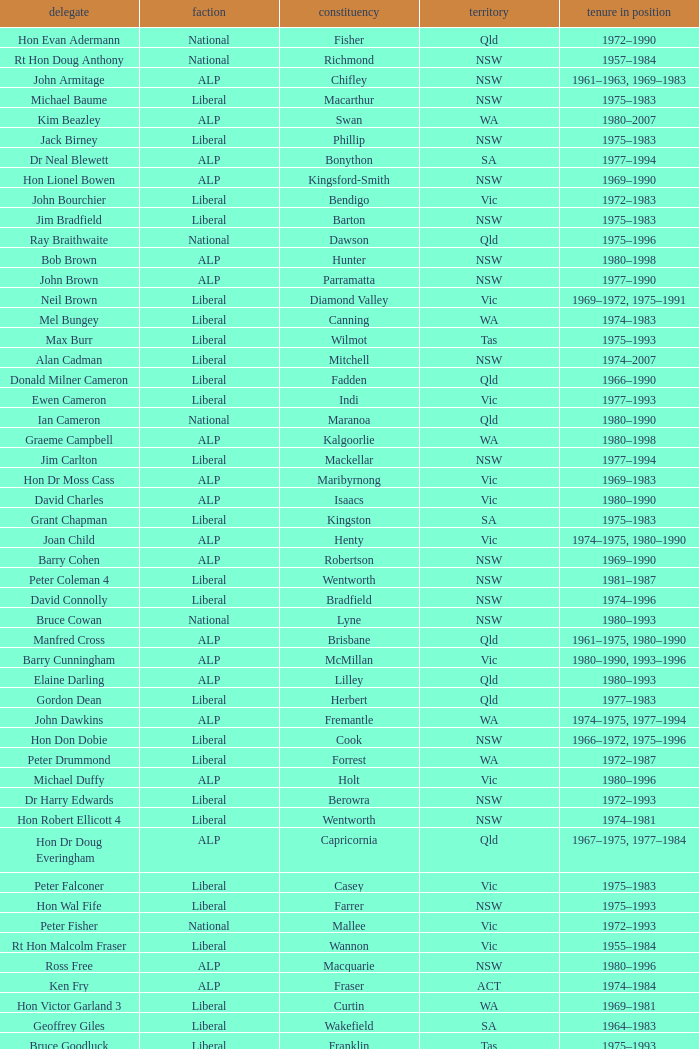When was Hon Les Johnson in office? 1955–1966, 1969–1984. 